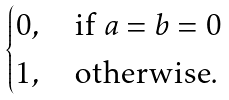<formula> <loc_0><loc_0><loc_500><loc_500>\begin{cases} 0 , \quad \text {if $a=b=0$} \\ 1 , \quad \text {otherwise} . \end{cases}</formula> 